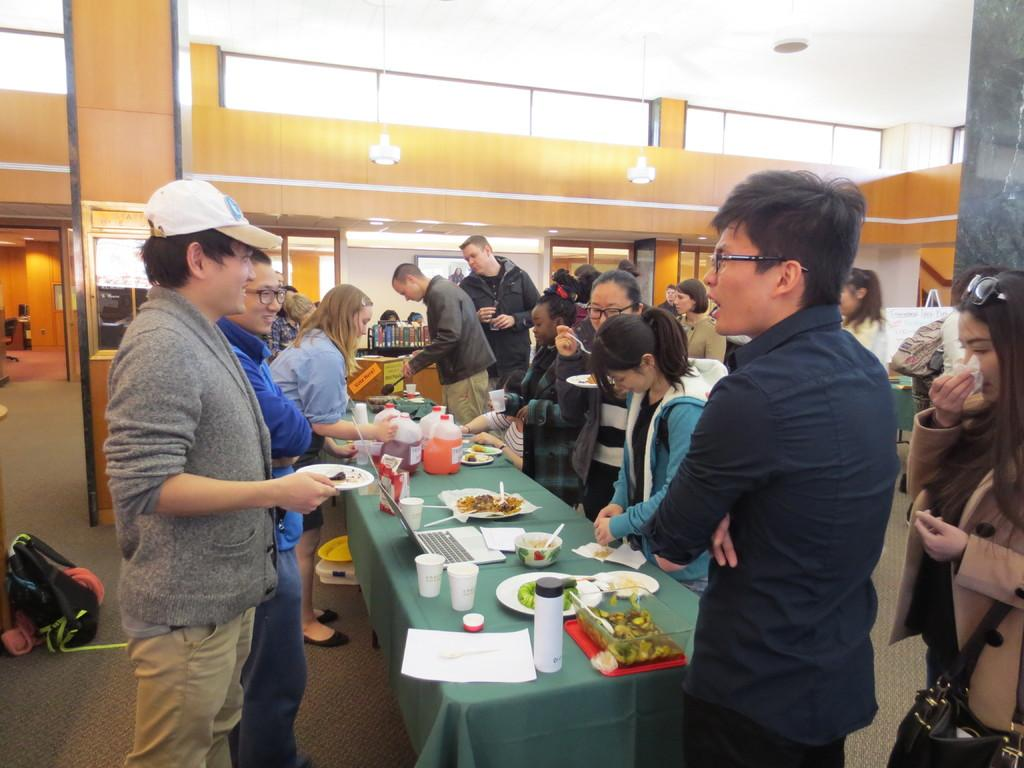What is happening in the image? There is a group of people in the image, and they are having food. How are the people positioned in the image? The people are standing in the image. Can you describe the activity the people are engaged in? The people are having food, which suggests they might be at a gathering or event. What type of joke can be heard being told by the person in the middle of the image? There is no person telling a joke in the image, as the provided facts only mention that the group of people is having food. 